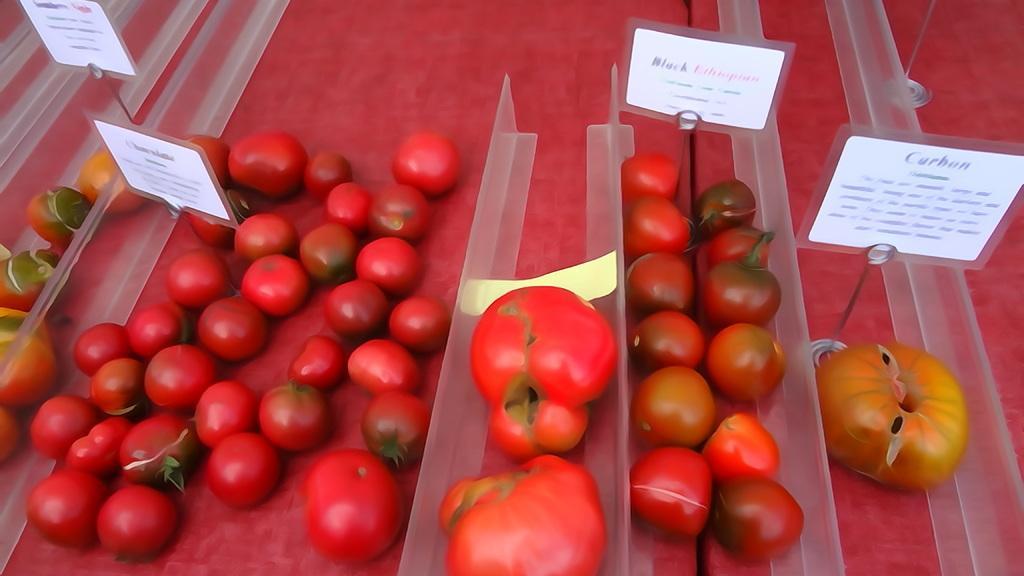How would you summarize this image in a sentence or two? In this there are few colorful vegetables visible might be on tables between them there are plastic divider visible, name plates visible between them. 